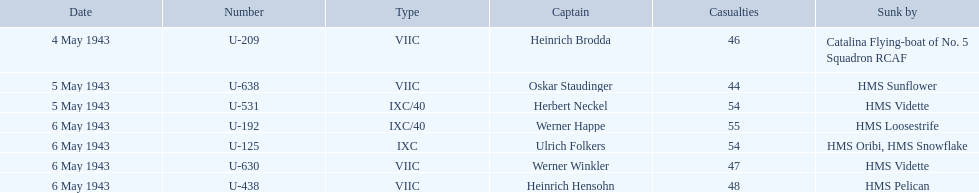What were the designations of the individuals responsible for sinking the convoys? Catalina Flying-boat of No. 5 Squadron RCAF, HMS Sunflower, HMS Vidette, HMS Loosestrife, HMS Oribi, HMS Snowflake, HMS Vidette, HMS Pelican. Which leader went under due to the hms pelican? Heinrich Hensohn. Who are all the commanders? Heinrich Brodda, Oskar Staudinger, Herbert Neckel, Werner Happe, Ulrich Folkers, Werner Winkler, Heinrich Hensohn. What led to the sinking of each commander? Catalina Flying-boat of No. 5 Squadron RCAF, HMS Sunflower, HMS Vidette, HMS Loosestrife, HMS Oribi, HMS Snowflake, HMS Vidette, HMS Pelican. Which was sunk by the hms pelican? Heinrich Hensohn. 